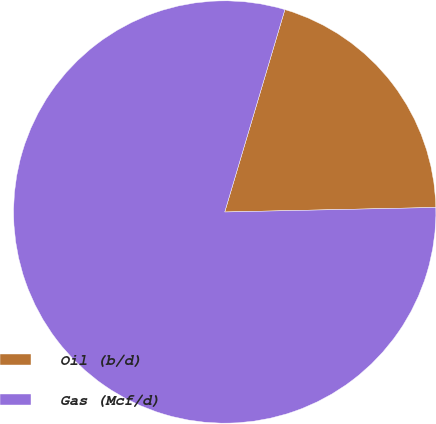Convert chart to OTSL. <chart><loc_0><loc_0><loc_500><loc_500><pie_chart><fcel>Oil (b/d)<fcel>Gas (Mcf/d)<nl><fcel>20.06%<fcel>79.94%<nl></chart> 